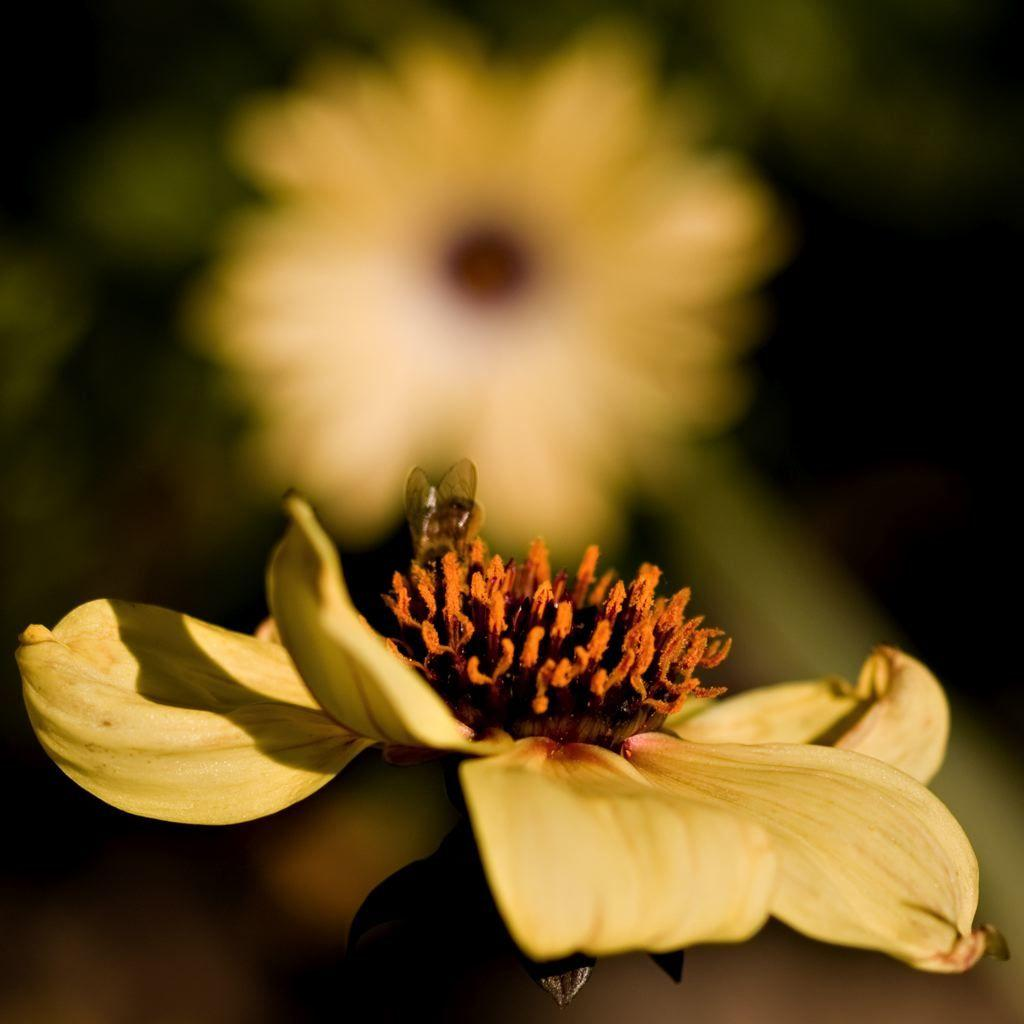What is the main subject of the image? There is a flower in the image. Where is the flower located in relation to the image? The flower is in the front of the image. How would you describe the background of the image? The background of the image is blurry. What type of silk fabric is draped over the flower in the image? There is no silk fabric present in the image; it only features a flower with a blurry background. 